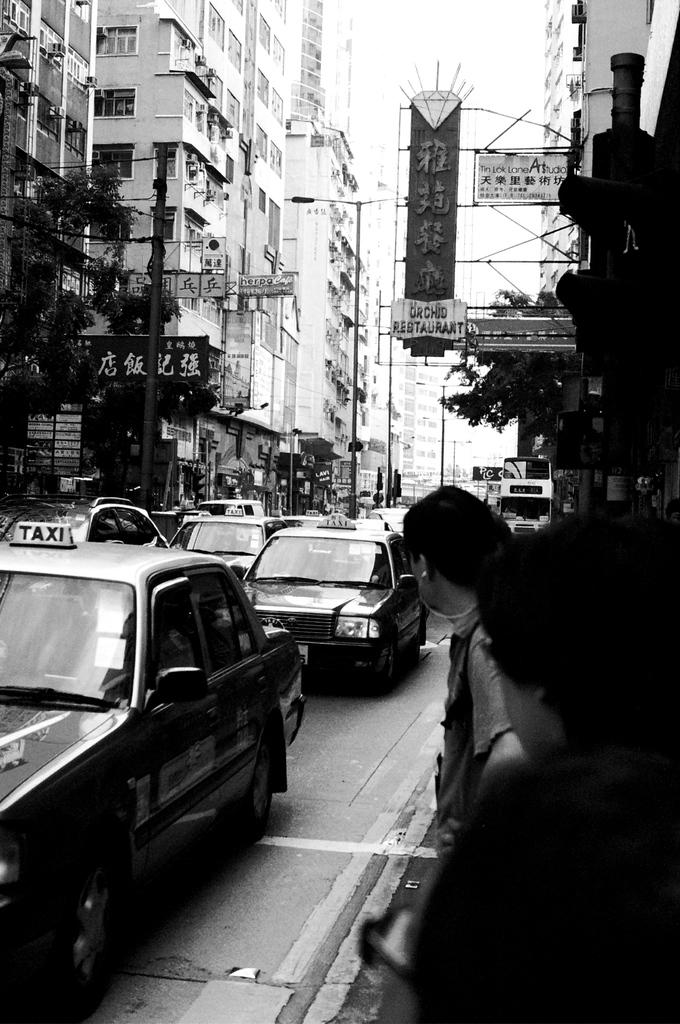<image>
Present a compact description of the photo's key features. A sign for the Orchid Restaurant hangs over the street in a city. 